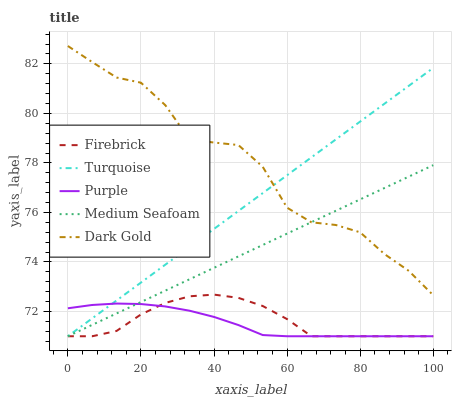Does Purple have the minimum area under the curve?
Answer yes or no. Yes. Does Dark Gold have the maximum area under the curve?
Answer yes or no. Yes. Does Firebrick have the minimum area under the curve?
Answer yes or no. No. Does Firebrick have the maximum area under the curve?
Answer yes or no. No. Is Medium Seafoam the smoothest?
Answer yes or no. Yes. Is Dark Gold the roughest?
Answer yes or no. Yes. Is Firebrick the smoothest?
Answer yes or no. No. Is Firebrick the roughest?
Answer yes or no. No. Does Purple have the lowest value?
Answer yes or no. Yes. Does Dark Gold have the lowest value?
Answer yes or no. No. Does Dark Gold have the highest value?
Answer yes or no. Yes. Does Firebrick have the highest value?
Answer yes or no. No. Is Firebrick less than Dark Gold?
Answer yes or no. Yes. Is Dark Gold greater than Purple?
Answer yes or no. Yes. Does Medium Seafoam intersect Purple?
Answer yes or no. Yes. Is Medium Seafoam less than Purple?
Answer yes or no. No. Is Medium Seafoam greater than Purple?
Answer yes or no. No. Does Firebrick intersect Dark Gold?
Answer yes or no. No. 